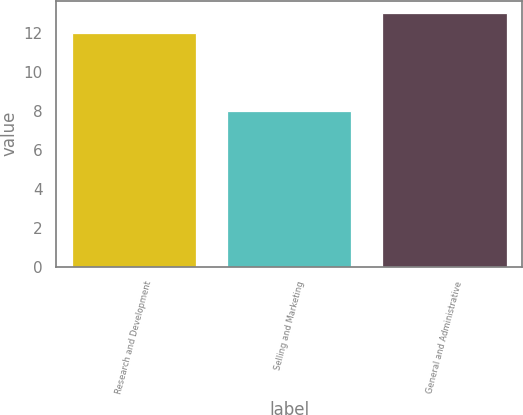<chart> <loc_0><loc_0><loc_500><loc_500><bar_chart><fcel>Research and Development<fcel>Selling and Marketing<fcel>General and Administrative<nl><fcel>12<fcel>8<fcel>13<nl></chart> 